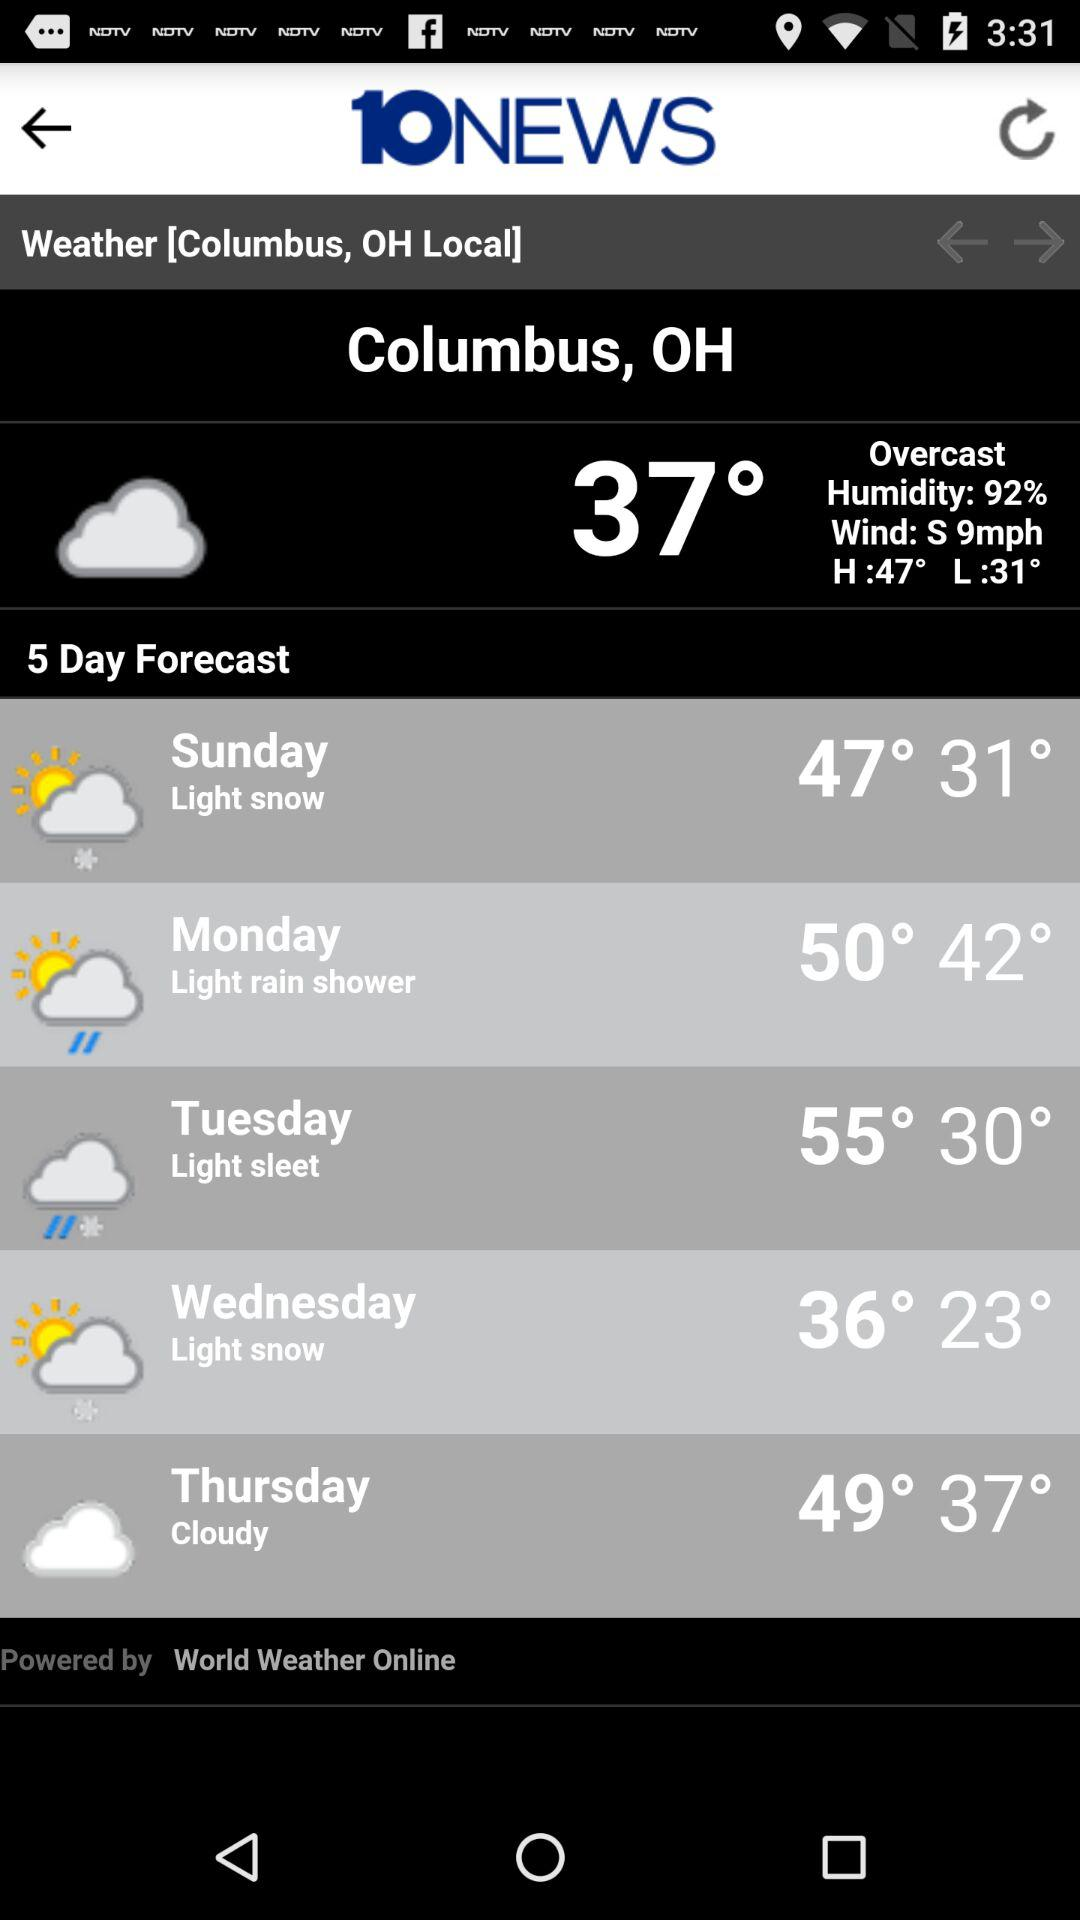What is the wind speed? The wind speed is 9 mph. 